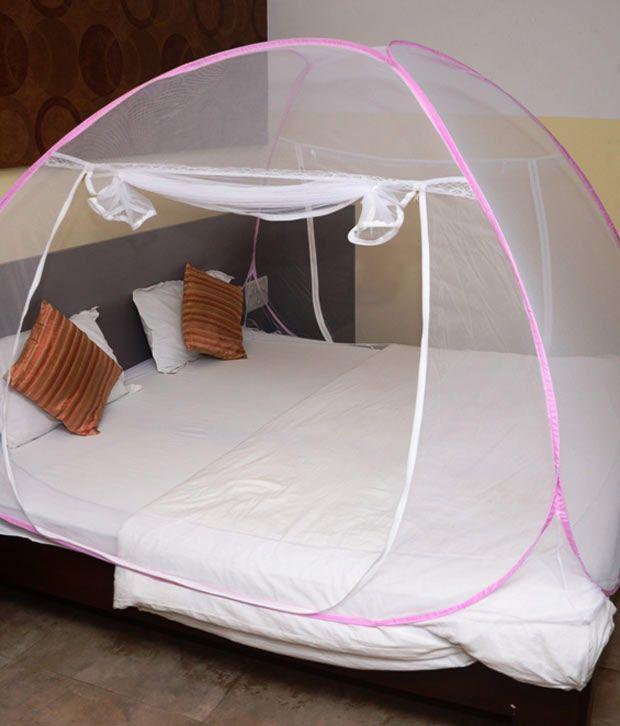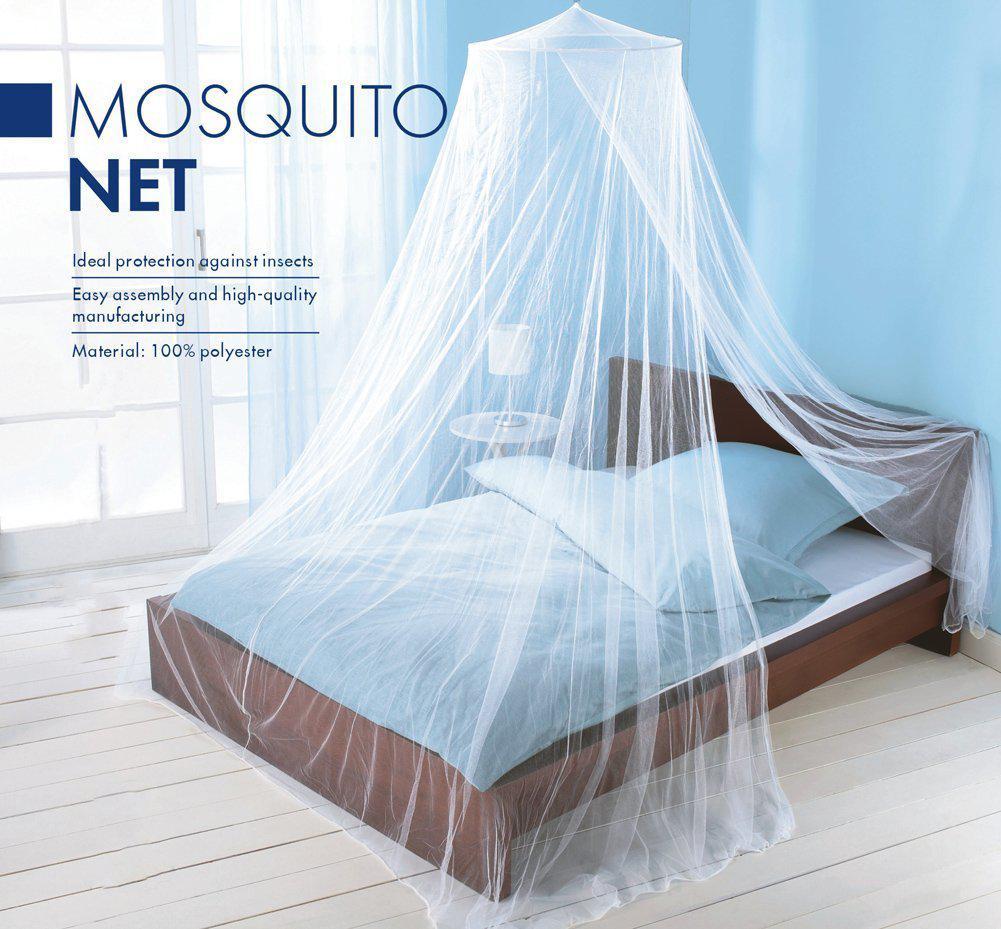The first image is the image on the left, the second image is the image on the right. Analyze the images presented: Is the assertion "The left image shows a dome canopy with an open side." valid? Answer yes or no. Yes. 